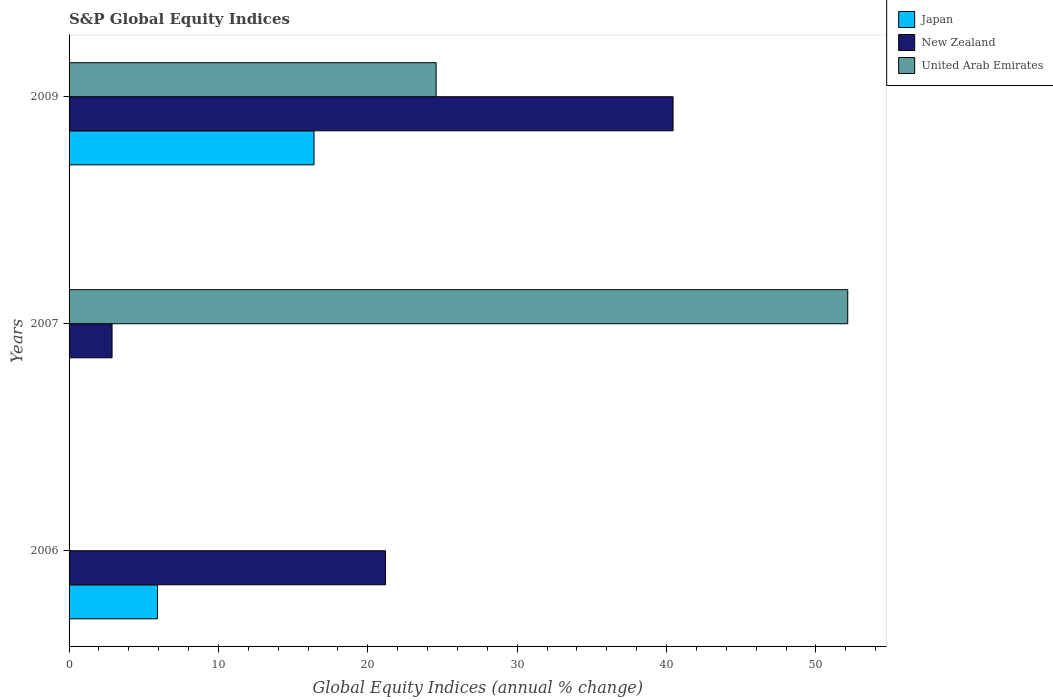How many groups of bars are there?
Your answer should be very brief. 3. Are the number of bars per tick equal to the number of legend labels?
Make the answer very short. No. How many bars are there on the 1st tick from the bottom?
Give a very brief answer. 2. In how many cases, is the number of bars for a given year not equal to the number of legend labels?
Your response must be concise. 2. What is the global equity indices in United Arab Emirates in 2009?
Keep it short and to the point. 24.57. Across all years, what is the maximum global equity indices in New Zealand?
Provide a short and direct response. 40.44. Across all years, what is the minimum global equity indices in United Arab Emirates?
Make the answer very short. 0. In which year was the global equity indices in United Arab Emirates maximum?
Provide a short and direct response. 2007. What is the total global equity indices in United Arab Emirates in the graph?
Keep it short and to the point. 76.71. What is the difference between the global equity indices in Japan in 2006 and that in 2009?
Your answer should be very brief. -10.48. What is the difference between the global equity indices in Japan in 2006 and the global equity indices in United Arab Emirates in 2009?
Give a very brief answer. -18.65. What is the average global equity indices in United Arab Emirates per year?
Make the answer very short. 25.57. In the year 2009, what is the difference between the global equity indices in Japan and global equity indices in New Zealand?
Offer a terse response. -24.04. What is the ratio of the global equity indices in New Zealand in 2006 to that in 2009?
Provide a short and direct response. 0.52. Is the global equity indices in New Zealand in 2006 less than that in 2009?
Give a very brief answer. Yes. What is the difference between the highest and the second highest global equity indices in New Zealand?
Ensure brevity in your answer.  19.25. What is the difference between the highest and the lowest global equity indices in Japan?
Your answer should be very brief. 16.4. In how many years, is the global equity indices in United Arab Emirates greater than the average global equity indices in United Arab Emirates taken over all years?
Give a very brief answer. 1. Is it the case that in every year, the sum of the global equity indices in Japan and global equity indices in New Zealand is greater than the global equity indices in United Arab Emirates?
Give a very brief answer. No. How many years are there in the graph?
Your answer should be very brief. 3. Are the values on the major ticks of X-axis written in scientific E-notation?
Ensure brevity in your answer.  No. Does the graph contain any zero values?
Offer a very short reply. Yes. How many legend labels are there?
Your answer should be compact. 3. What is the title of the graph?
Keep it short and to the point. S&P Global Equity Indices. What is the label or title of the X-axis?
Your answer should be compact. Global Equity Indices (annual % change). What is the Global Equity Indices (annual % change) in Japan in 2006?
Your response must be concise. 5.92. What is the Global Equity Indices (annual % change) of New Zealand in 2006?
Your answer should be compact. 21.19. What is the Global Equity Indices (annual % change) of United Arab Emirates in 2006?
Keep it short and to the point. 0. What is the Global Equity Indices (annual % change) in Japan in 2007?
Make the answer very short. 0. What is the Global Equity Indices (annual % change) in New Zealand in 2007?
Provide a succinct answer. 2.88. What is the Global Equity Indices (annual % change) in United Arab Emirates in 2007?
Your response must be concise. 52.13. What is the Global Equity Indices (annual % change) of Japan in 2009?
Provide a short and direct response. 16.4. What is the Global Equity Indices (annual % change) in New Zealand in 2009?
Ensure brevity in your answer.  40.44. What is the Global Equity Indices (annual % change) of United Arab Emirates in 2009?
Provide a succinct answer. 24.57. Across all years, what is the maximum Global Equity Indices (annual % change) in Japan?
Offer a very short reply. 16.4. Across all years, what is the maximum Global Equity Indices (annual % change) of New Zealand?
Offer a very short reply. 40.44. Across all years, what is the maximum Global Equity Indices (annual % change) of United Arab Emirates?
Your answer should be very brief. 52.13. Across all years, what is the minimum Global Equity Indices (annual % change) in New Zealand?
Give a very brief answer. 2.88. What is the total Global Equity Indices (annual % change) in Japan in the graph?
Ensure brevity in your answer.  22.32. What is the total Global Equity Indices (annual % change) in New Zealand in the graph?
Your response must be concise. 64.5. What is the total Global Equity Indices (annual % change) in United Arab Emirates in the graph?
Offer a terse response. 76.71. What is the difference between the Global Equity Indices (annual % change) of New Zealand in 2006 and that in 2007?
Ensure brevity in your answer.  18.31. What is the difference between the Global Equity Indices (annual % change) of Japan in 2006 and that in 2009?
Your answer should be very brief. -10.48. What is the difference between the Global Equity Indices (annual % change) in New Zealand in 2006 and that in 2009?
Offer a terse response. -19.25. What is the difference between the Global Equity Indices (annual % change) of New Zealand in 2007 and that in 2009?
Keep it short and to the point. -37.56. What is the difference between the Global Equity Indices (annual % change) in United Arab Emirates in 2007 and that in 2009?
Your answer should be compact. 27.56. What is the difference between the Global Equity Indices (annual % change) in Japan in 2006 and the Global Equity Indices (annual % change) in New Zealand in 2007?
Your answer should be very brief. 3.04. What is the difference between the Global Equity Indices (annual % change) of Japan in 2006 and the Global Equity Indices (annual % change) of United Arab Emirates in 2007?
Offer a very short reply. -46.21. What is the difference between the Global Equity Indices (annual % change) in New Zealand in 2006 and the Global Equity Indices (annual % change) in United Arab Emirates in 2007?
Provide a short and direct response. -30.94. What is the difference between the Global Equity Indices (annual % change) of Japan in 2006 and the Global Equity Indices (annual % change) of New Zealand in 2009?
Make the answer very short. -34.52. What is the difference between the Global Equity Indices (annual % change) of Japan in 2006 and the Global Equity Indices (annual % change) of United Arab Emirates in 2009?
Your response must be concise. -18.65. What is the difference between the Global Equity Indices (annual % change) in New Zealand in 2006 and the Global Equity Indices (annual % change) in United Arab Emirates in 2009?
Keep it short and to the point. -3.39. What is the difference between the Global Equity Indices (annual % change) in New Zealand in 2007 and the Global Equity Indices (annual % change) in United Arab Emirates in 2009?
Provide a succinct answer. -21.7. What is the average Global Equity Indices (annual % change) in Japan per year?
Your response must be concise. 7.44. What is the average Global Equity Indices (annual % change) of New Zealand per year?
Your response must be concise. 21.5. What is the average Global Equity Indices (annual % change) in United Arab Emirates per year?
Your answer should be very brief. 25.57. In the year 2006, what is the difference between the Global Equity Indices (annual % change) in Japan and Global Equity Indices (annual % change) in New Zealand?
Provide a short and direct response. -15.27. In the year 2007, what is the difference between the Global Equity Indices (annual % change) in New Zealand and Global Equity Indices (annual % change) in United Arab Emirates?
Provide a short and direct response. -49.25. In the year 2009, what is the difference between the Global Equity Indices (annual % change) in Japan and Global Equity Indices (annual % change) in New Zealand?
Keep it short and to the point. -24.04. In the year 2009, what is the difference between the Global Equity Indices (annual % change) of Japan and Global Equity Indices (annual % change) of United Arab Emirates?
Make the answer very short. -8.18. In the year 2009, what is the difference between the Global Equity Indices (annual % change) in New Zealand and Global Equity Indices (annual % change) in United Arab Emirates?
Offer a very short reply. 15.86. What is the ratio of the Global Equity Indices (annual % change) of New Zealand in 2006 to that in 2007?
Keep it short and to the point. 7.36. What is the ratio of the Global Equity Indices (annual % change) in Japan in 2006 to that in 2009?
Keep it short and to the point. 0.36. What is the ratio of the Global Equity Indices (annual % change) of New Zealand in 2006 to that in 2009?
Provide a succinct answer. 0.52. What is the ratio of the Global Equity Indices (annual % change) of New Zealand in 2007 to that in 2009?
Your response must be concise. 0.07. What is the ratio of the Global Equity Indices (annual % change) of United Arab Emirates in 2007 to that in 2009?
Your response must be concise. 2.12. What is the difference between the highest and the second highest Global Equity Indices (annual % change) in New Zealand?
Give a very brief answer. 19.25. What is the difference between the highest and the lowest Global Equity Indices (annual % change) in Japan?
Your response must be concise. 16.4. What is the difference between the highest and the lowest Global Equity Indices (annual % change) of New Zealand?
Make the answer very short. 37.56. What is the difference between the highest and the lowest Global Equity Indices (annual % change) of United Arab Emirates?
Give a very brief answer. 52.13. 